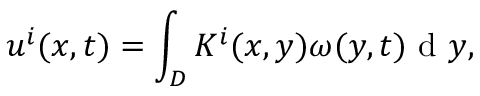Convert formula to latex. <formula><loc_0><loc_0><loc_500><loc_500>u ^ { i } ( x , t ) = \int _ { D } K ^ { i } ( x , y ) \omega ( y , t ) d y ,</formula> 